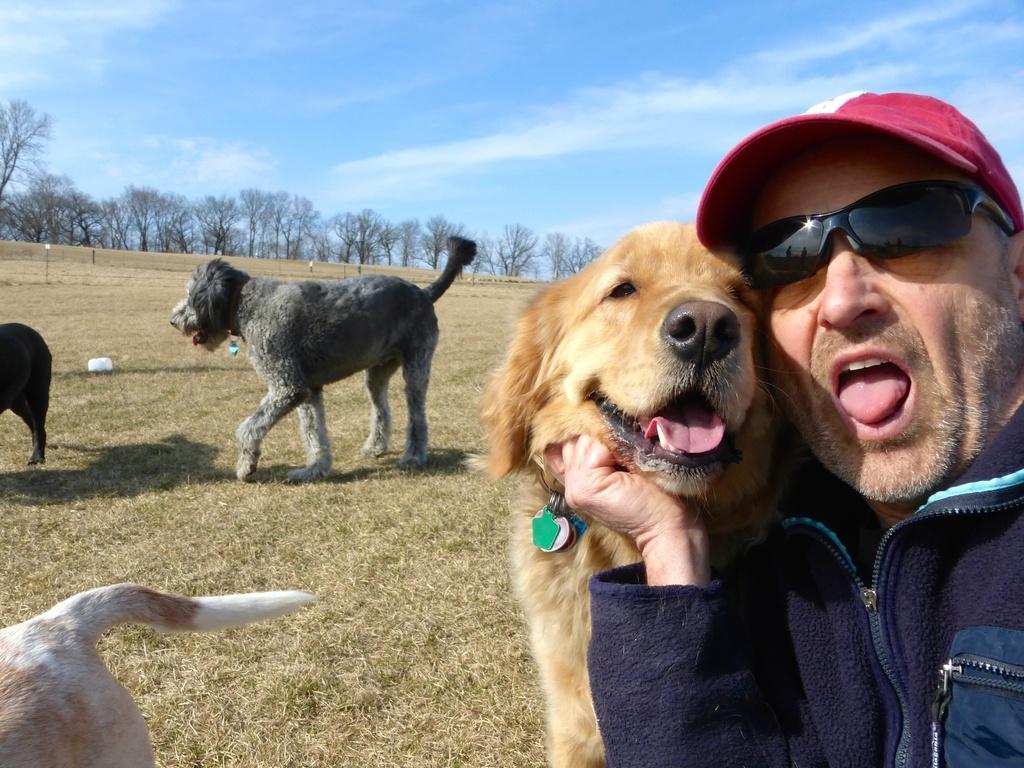In one or two sentences, can you explain what this image depicts? at the right there is a person and a dog. behind him there are more dogs. behind them there are trees. 